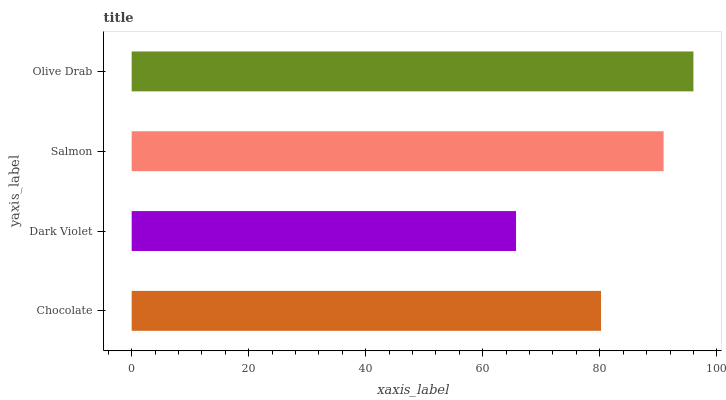Is Dark Violet the minimum?
Answer yes or no. Yes. Is Olive Drab the maximum?
Answer yes or no. Yes. Is Salmon the minimum?
Answer yes or no. No. Is Salmon the maximum?
Answer yes or no. No. Is Salmon greater than Dark Violet?
Answer yes or no. Yes. Is Dark Violet less than Salmon?
Answer yes or no. Yes. Is Dark Violet greater than Salmon?
Answer yes or no. No. Is Salmon less than Dark Violet?
Answer yes or no. No. Is Salmon the high median?
Answer yes or no. Yes. Is Chocolate the low median?
Answer yes or no. Yes. Is Chocolate the high median?
Answer yes or no. No. Is Olive Drab the low median?
Answer yes or no. No. 